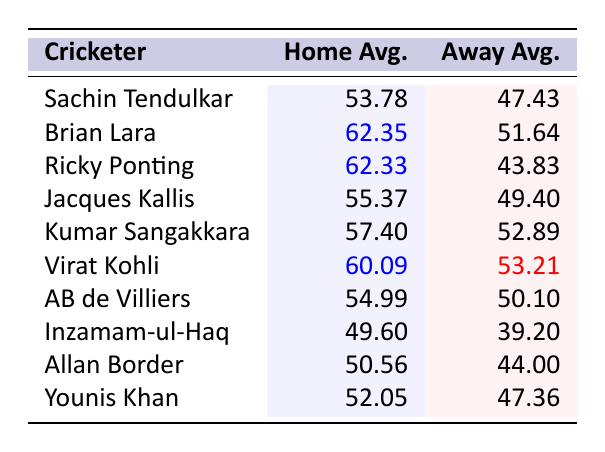What is the home average of Brian Lara? The table lists Brian Lara's home average as 62.35, which is noted directly next to his name.
Answer: 62.35 What is the away average for Inzamam-ul-Haq? The table shows Inzamam-ul-Haq's away average as 39.20, which can be found in the corresponding column.
Answer: 39.20 Who has a higher home average, Ricky Ponting or Jacques Kallis? Ricky Ponting's home average is 62.33, while Jacques Kallis's is 55.37. Comparing these values shows that Ricky Ponting has the higher home average.
Answer: Ricky Ponting What is the difference between the home averages of Virat Kohli and AB de Villiers? Virat Kohli's home average is 60.09 and AB de Villiers's is 54.99. The difference is calculated as 60.09 - 54.99 = 5.10.
Answer: 5.10 Is Sachin Tendulkar's away average higher than his home average? Looking at the table, Sachin Tendulkar's home average is 53.78 and his away average is 47.43. Since 47.43 is less than 53.78, the statement is false.
Answer: No Which cricketer has the highest away average? The table indicates that Brian Lara has the highest away average at 51.64 when compared to others listed.
Answer: Brian Lara What is the average of the home averages for all cricketers in the table? To find the average, sum all the home averages: 53.78 + 62.35 + 62.33 + 55.37 + 57.40 + 60.09 + 54.99 + 49.60 + 50.56 + 52.05 =  576.52. Divide by the number of cricketers, 10: 576.52 / 10 = 57.652.
Answer: 57.65 Which cricketer has the largest difference between home and away averages? Calculating the differences: Sachin Tendulkar (6.35), Brian Lara (10.71), Ricky Ponting (18.50), Jacques Kallis (5.97), Kumar Sangakkara (4.51), Virat Kohli (6.88), AB de Villiers (4.89), Inzamam-ul-Haq (10.40), Allan Border (6.56), Younis Khan (4.69). The largest difference is Ricky Ponting at 18.50.
Answer: Ricky Ponting Are there more cricketers with home averages above 55 than below 50? The cricketers with home averages above 55 are Brian Lara, Ricky Ponting, Kumar Sangakkara, Virat Kohli, and Jacques Kallis (5 cricketers). Below 50 is Inzamam-ul-Haq (1 cricketer). Since 5 is greater than 1, the answer is yes.
Answer: Yes Which cricketer's home average is closest to their away average? To find this, we compare the absolute differences: Sachin Tendulkar (6.35), Brian Lara (10.71), Ricky Ponting (18.50), Jacques Kallis (5.97), Kumar Sangakkara (4.51), Virat Kohli (6.88), AB de Villiers (4.89), Inzamam-ul-Haq (10.40), Allan Border (6.56), Younis Khan (4.69). Kumar Sangakkara has the smallest difference of 4.51, thus is the answer.
Answer: Kumar Sangakkara 